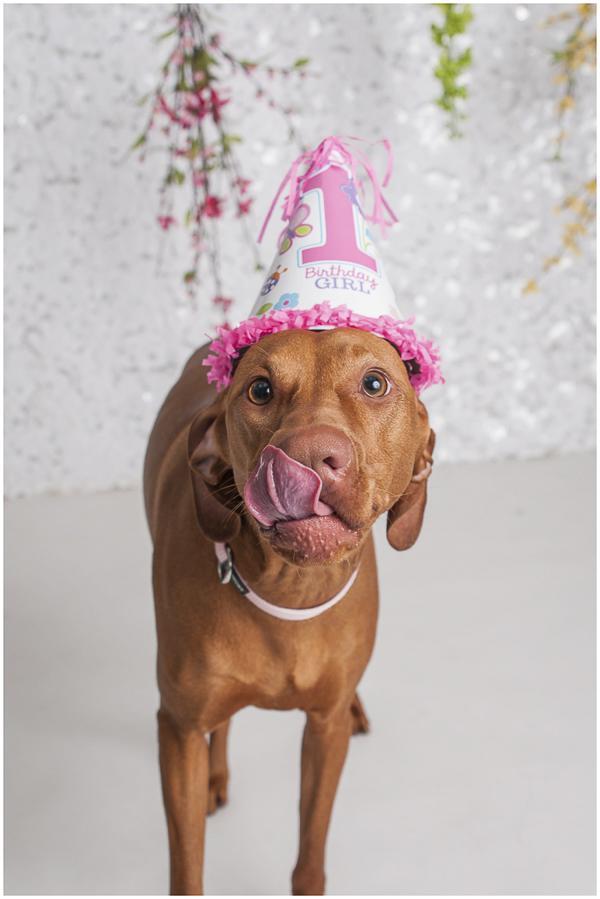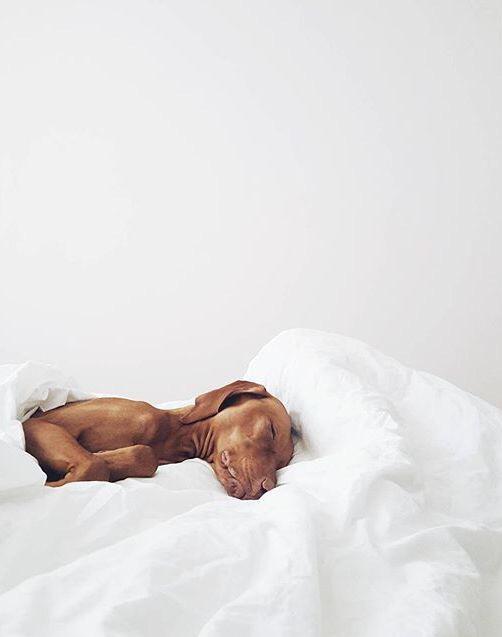The first image is the image on the left, the second image is the image on the right. Evaluate the accuracy of this statement regarding the images: "A dog is wearing a knit hat.". Is it true? Answer yes or no. No. The first image is the image on the left, the second image is the image on the right. Considering the images on both sides, is "The right image contains a brown dog that is wearing clothing on their head." valid? Answer yes or no. No. 